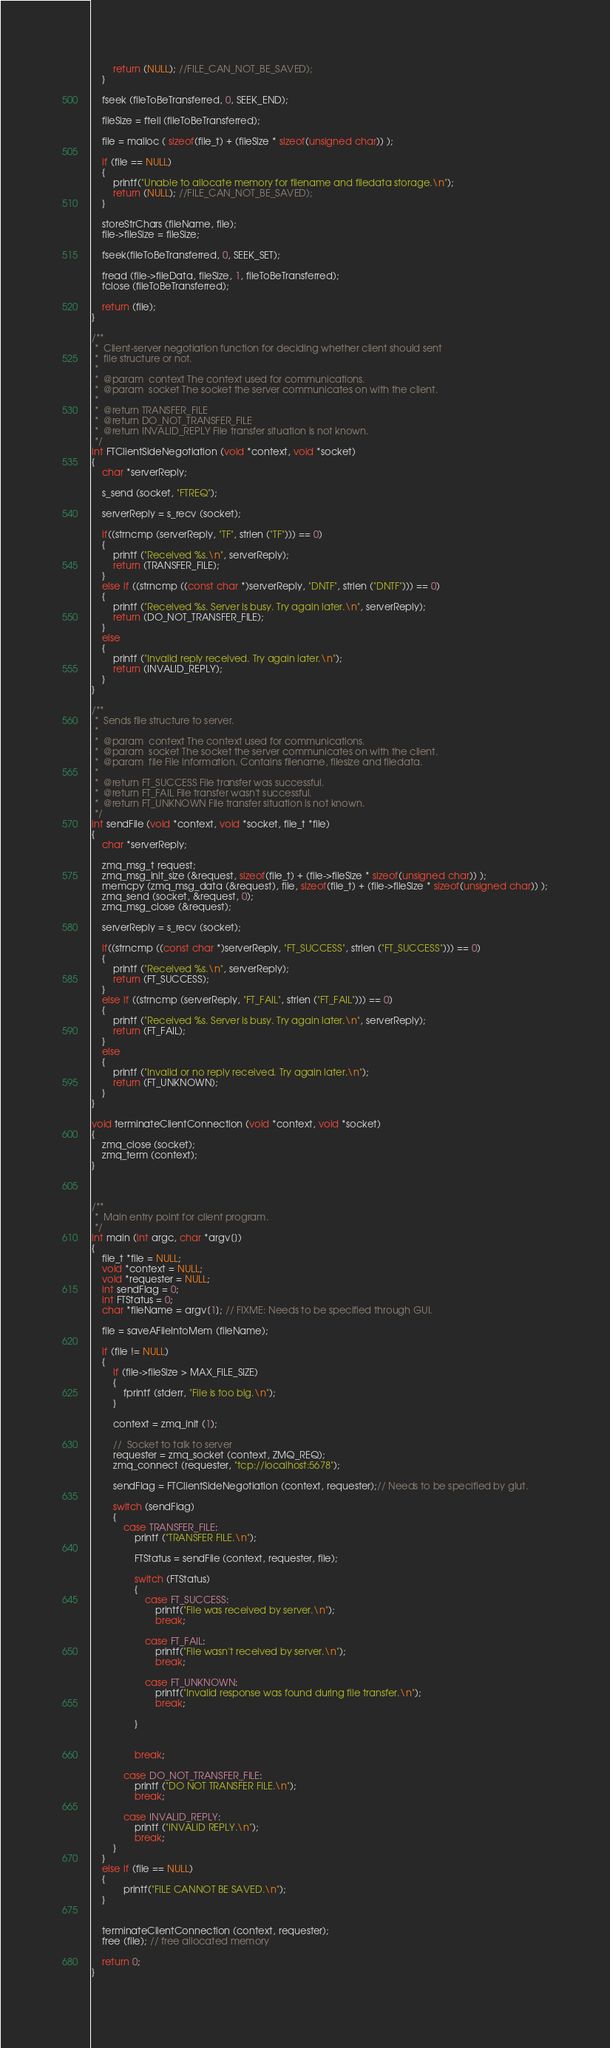Convert code to text. <code><loc_0><loc_0><loc_500><loc_500><_C_>        return (NULL); //FILE_CAN_NOT_BE_SAVED);
    }
    
    fseek (fileToBeTransferred, 0, SEEK_END);
    
    fileSize = ftell (fileToBeTransferred);
    
    file = malloc ( sizeof(file_t) + (fileSize * sizeof(unsigned char)) );
    
    if (file == NULL)
    {
        printf("Unable to allocate memory for filename and filedata storage.\n");
        return (NULL); //FILE_CAN_NOT_BE_SAVED);
    }
    
    storeStrChars (fileName, file);
    file->fileSize = fileSize;
    
    fseek(fileToBeTransferred, 0, SEEK_SET);
      
    fread (file->fileData, fileSize, 1, fileToBeTransferred);
    fclose (fileToBeTransferred); 
    
    return (file);
}

/**
 *  Client-server negotiation function for deciding whether client should sent
 *  file structure or not.
 *
 *  @param  context The context used for communications.
 *  @param  socket The socket the server communicates on with the client.  
 *
 *  @return TRANSFER_FILE 
 *  @return DO_NOT_TRANSFER_FILE   
 *  @return INVALID_REPLY File transfer situation is not known.    
 */
int FTClientSideNegotiation (void *context, void *socket)
{
    char *serverReply;
    
    s_send (socket, "FTREQ");

    serverReply = s_recv (socket);
    
    if((strncmp (serverReply, "TF", strlen ("TF"))) == 0)
    {
        printf ("Received %s.\n", serverReply);
        return (TRANSFER_FILE);
    }
    else if ((strncmp ((const char *)serverReply, "DNTF", strlen ("DNTF"))) == 0)
    {
        printf ("Received %s. Server is busy. Try again later.\n", serverReply);
        return (DO_NOT_TRANSFER_FILE);
    }
    else 
    {
        printf ("Invalid reply received. Try again later.\n");
        return (INVALID_REPLY);
    }
}

/**
 *  Sends file structure to server.
 *
 *  @param  context The context used for communications.
 *  @param  socket The socket the server communicates on with the client.  
 *  @param  file File information. Contains filename, filesize and filedata.
 *
 *  @return FT_SUCCESS File transfer was successful.
 *  @return FT_FAIL File transfer wasn't successful.  
 *  @return FT_UNKNOWN File transfer situation is not known.    
 */
int sendFile (void *context, void *socket, file_t *file)
{
    char *serverReply;
    
    zmq_msg_t request;
    zmq_msg_init_size (&request, sizeof(file_t) + (file->fileSize * sizeof(unsigned char)) );
    memcpy (zmq_msg_data (&request), file, sizeof(file_t) + (file->fileSize * sizeof(unsigned char)) );
    zmq_send (socket, &request, 0);
    zmq_msg_close (&request);

    serverReply = s_recv (socket); 

    if((strncmp ((const char *)serverReply, "FT_SUCCESS", strlen ("FT_SUCCESS"))) == 0)
    {
        printf ("Received %s.\n", serverReply);
        return (FT_SUCCESS);
    }
    else if ((strncmp (serverReply, "FT_FAIL", strlen ("FT_FAIL"))) == 0)
    {
        printf ("Received %s. Server is busy. Try again later.\n", serverReply);
        return (FT_FAIL);
    }
    else
    {
        printf ("Invalid or no reply received. Try again later.\n");
        return (FT_UNKNOWN);
    }
}

void terminateClientConnection (void *context, void *socket)
{
    zmq_close (socket);
    zmq_term (context);
}



/**
 *  Main entry point for client program.    
 */
int main (int argc, char *argv[])
{
    file_t *file = NULL;
    void *context = NULL;
    void *requester = NULL;
    int sendFlag = 0;
    int FTStatus = 0;
    char *fileName = argv[1]; // FIXME: Needs to be specified through GUI.
    
    file = saveAFileIntoMem (fileName);
    
    if (file != NULL)
    {
        if (file->fileSize > MAX_FILE_SIZE)
        {
            fprintf (stderr, "File is too big.\n");
        }
    
        context = zmq_init (1);

        //  Socket to talk to server
        requester = zmq_socket (context, ZMQ_REQ);
        zmq_connect (requester, "tcp://localhost:5678"); 
        
        sendFlag = FTClientSideNegotiation (context, requester);// Needs to be specified by glut.
        
        switch (sendFlag)
        {
            case TRANSFER_FILE:
                printf ("TRANSFER FILE.\n");
                
                FTStatus = sendFile (context, requester, file);
                 
                switch (FTStatus)
                {
                    case FT_SUCCESS:
                        printf("File was received by server.\n");
                        break;
                        
                    case FT_FAIL:
                        printf("File wasn't received by server.\n");
                        break;
                        
                    case FT_UNKNOWN:
                        printf("Invalid response was found during file transfer.\n");
                        break;
                        
                }
                        
                
                break;
                
            case DO_NOT_TRANSFER_FILE:
                printf ("DO NOT TRANSFER FILE.\n");
                break;
                
            case INVALID_REPLY:
                printf ("INVALID REPLY.\n");
                break;
        }
    }
    else if (file == NULL)
    {
            printf("FILE CANNOT BE SAVED.\n");
    }
            
            
    terminateClientConnection (context, requester);
    free (file); // free allocated memory 
    
    return 0;
}
 
</code> 